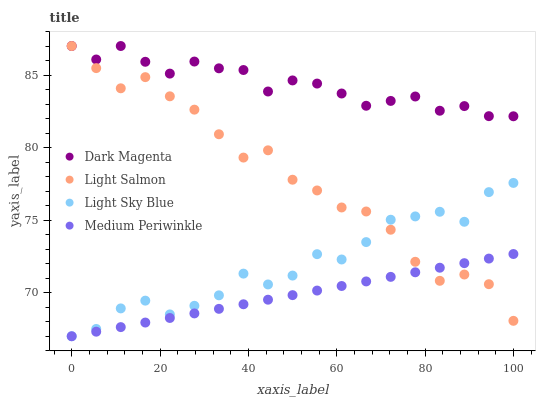Does Medium Periwinkle have the minimum area under the curve?
Answer yes or no. Yes. Does Dark Magenta have the maximum area under the curve?
Answer yes or no. Yes. Does Light Sky Blue have the minimum area under the curve?
Answer yes or no. No. Does Light Sky Blue have the maximum area under the curve?
Answer yes or no. No. Is Medium Periwinkle the smoothest?
Answer yes or no. Yes. Is Light Sky Blue the roughest?
Answer yes or no. Yes. Is Light Sky Blue the smoothest?
Answer yes or no. No. Is Medium Periwinkle the roughest?
Answer yes or no. No. Does Light Sky Blue have the lowest value?
Answer yes or no. Yes. Does Dark Magenta have the lowest value?
Answer yes or no. No. Does Dark Magenta have the highest value?
Answer yes or no. Yes. Does Light Sky Blue have the highest value?
Answer yes or no. No. Is Light Sky Blue less than Dark Magenta?
Answer yes or no. Yes. Is Dark Magenta greater than Medium Periwinkle?
Answer yes or no. Yes. Does Light Sky Blue intersect Light Salmon?
Answer yes or no. Yes. Is Light Sky Blue less than Light Salmon?
Answer yes or no. No. Is Light Sky Blue greater than Light Salmon?
Answer yes or no. No. Does Light Sky Blue intersect Dark Magenta?
Answer yes or no. No. 